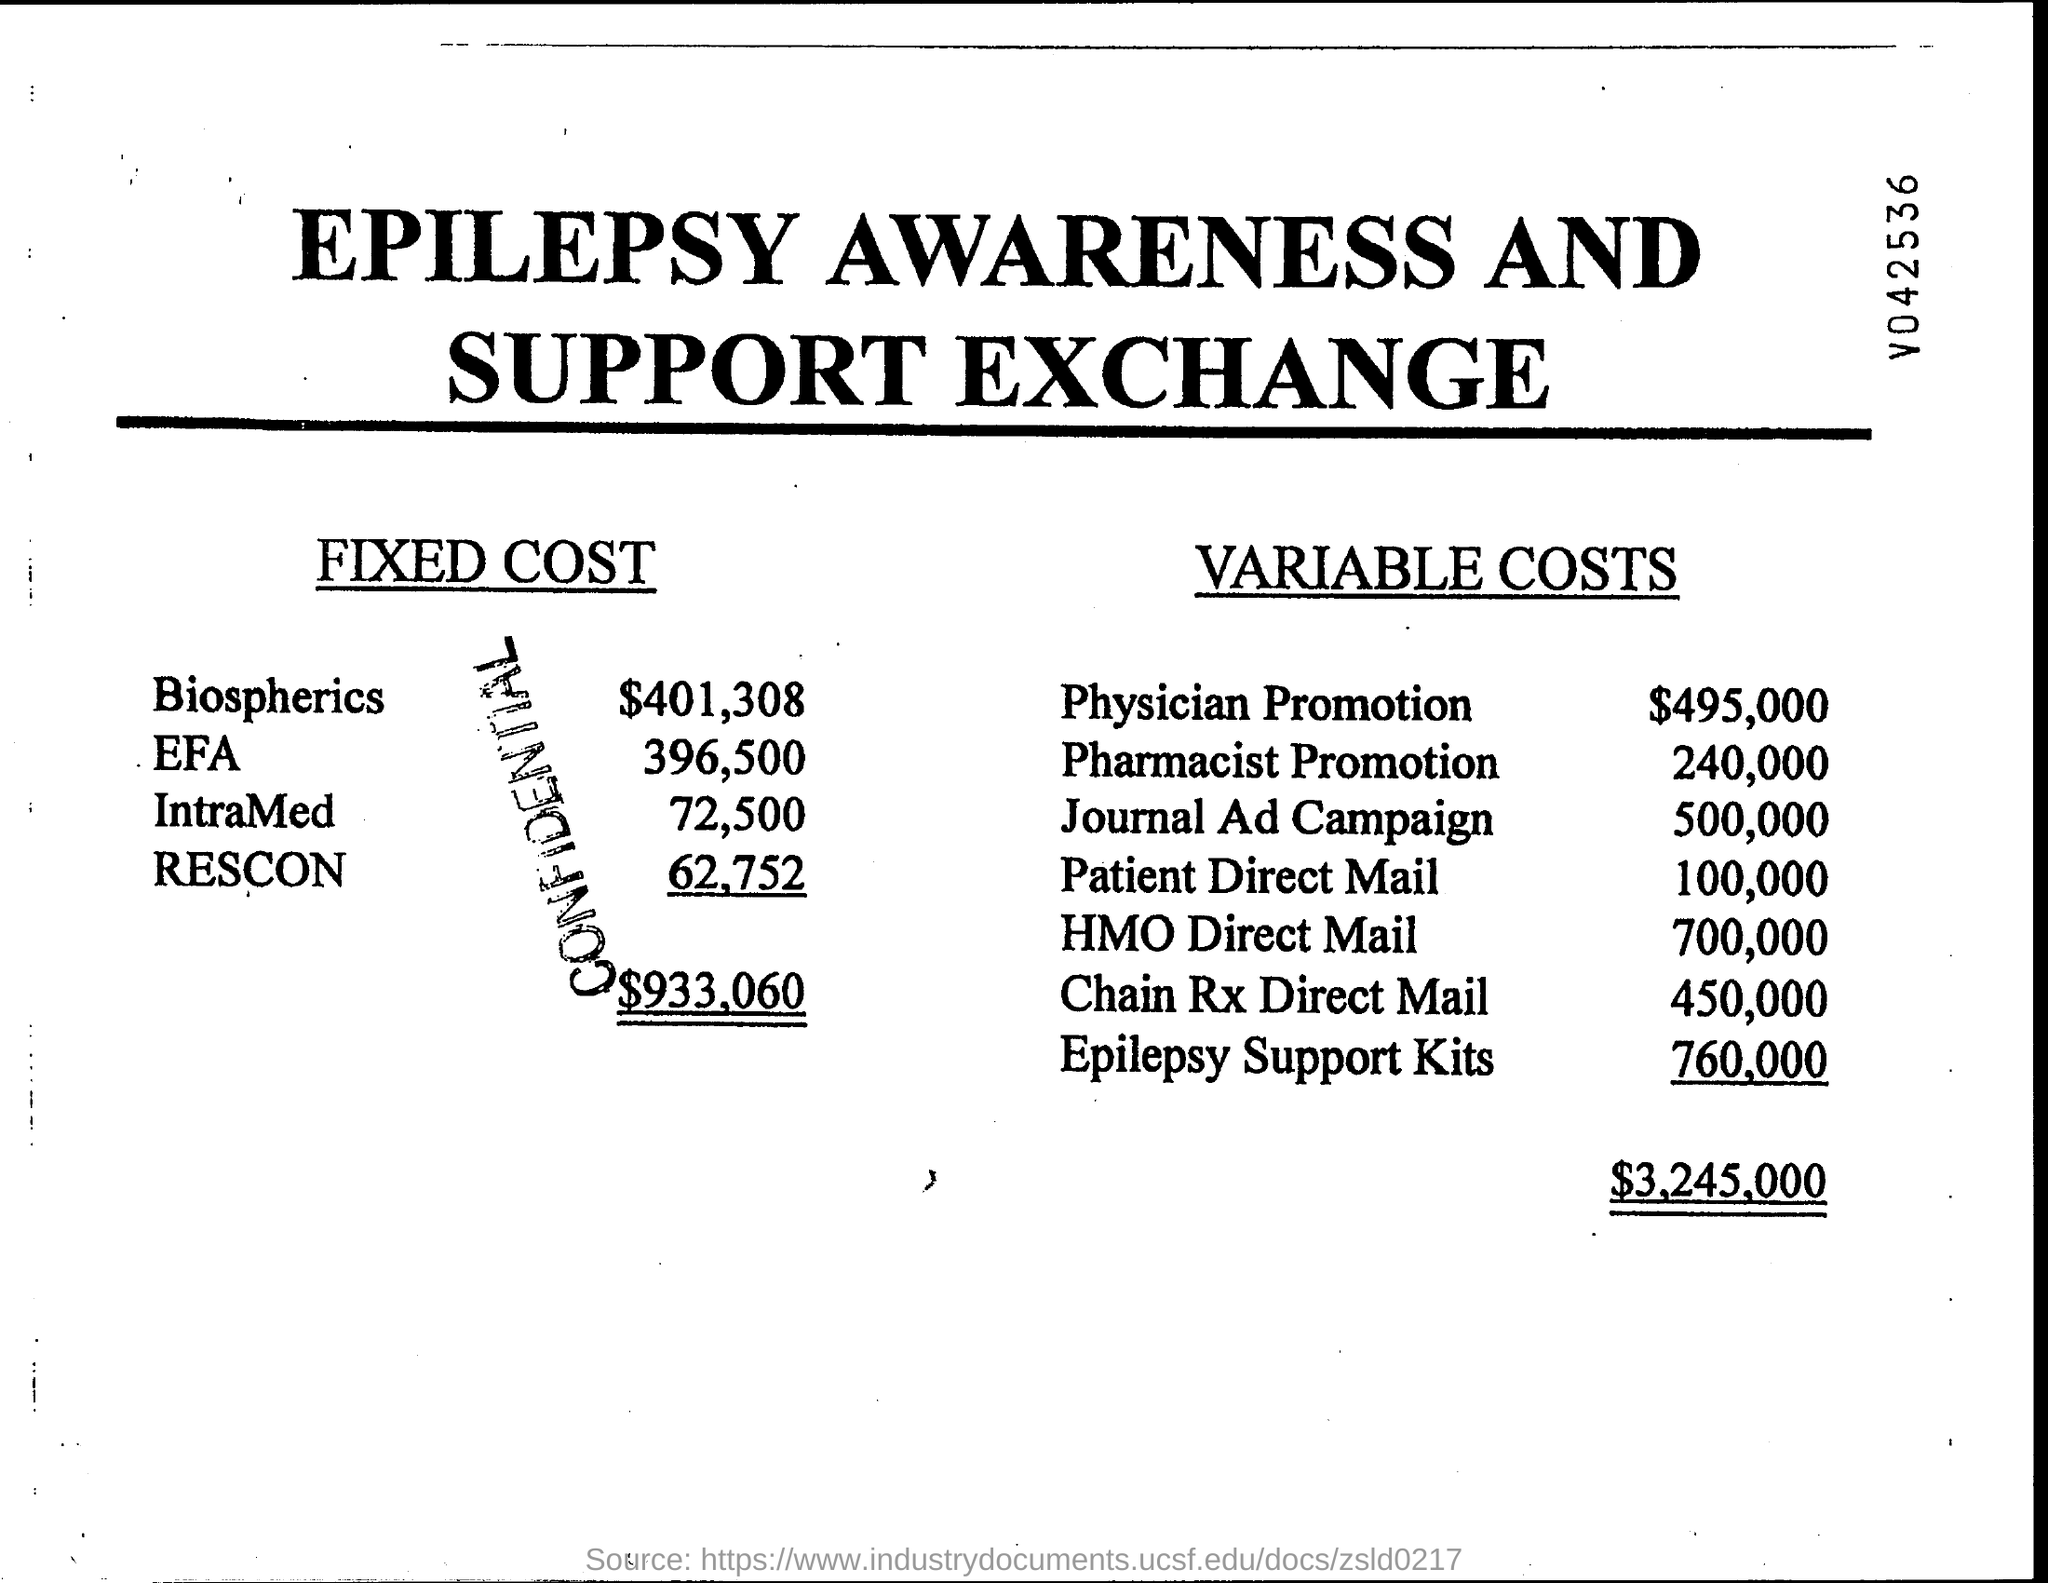What is the total of fixed cost?
Give a very brief answer. $933,060. What is the total of variable costs?
Make the answer very short. $3,245,000. What is the amount of physician promotion in variable costs ?
Provide a succinct answer. $495,000. What is the amount of biospherics in fixed cost?
Ensure brevity in your answer.  $401,308. 